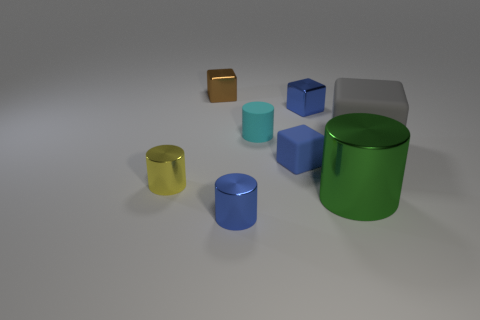There is another block that is the same color as the tiny rubber cube; what size is it?
Your response must be concise. Small. How many yellow objects are metal cylinders or large matte cylinders?
Provide a short and direct response. 1. Are there any metal things of the same color as the small matte cube?
Ensure brevity in your answer.  Yes. Are there any small yellow things made of the same material as the large green object?
Offer a terse response. Yes. What shape is the thing that is both to the right of the small blue matte block and in front of the gray rubber object?
Provide a short and direct response. Cylinder. How many big objects are blue rubber blocks or yellow rubber balls?
Offer a very short reply. 0. What is the material of the big gray block?
Make the answer very short. Rubber. What number of other things are there of the same shape as the large gray matte thing?
Your response must be concise. 3. What is the size of the gray rubber object?
Give a very brief answer. Large. There is a matte thing that is both behind the small blue rubber block and on the left side of the large gray cube; what size is it?
Give a very brief answer. Small. 